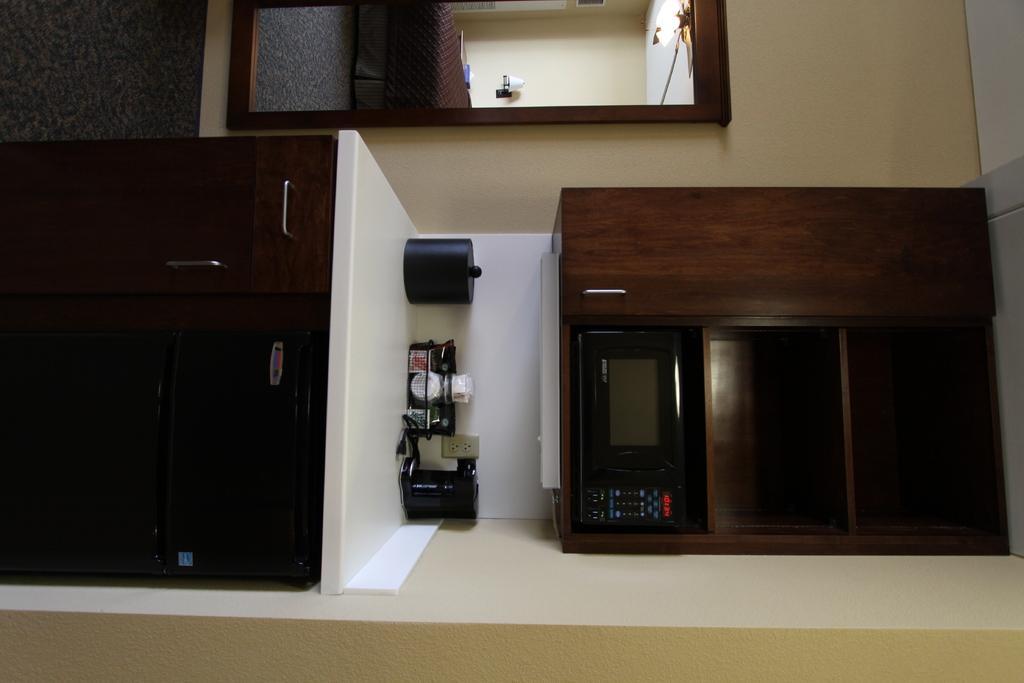Describe this image in one or two sentences. In the image we can see wooden cupboards, oven and kitchen stuff. Here we can see the wall, door and the light. 